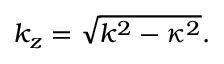<formula> <loc_0><loc_0><loc_500><loc_500>k _ { z } = \sqrt { k ^ { 2 } - \kappa ^ { 2 } } .</formula> 